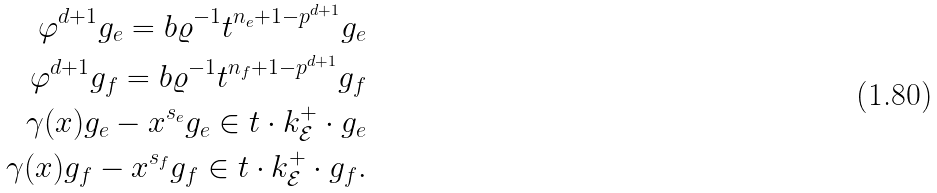Convert formula to latex. <formula><loc_0><loc_0><loc_500><loc_500>\varphi ^ { d + 1 } g _ { e } = b \varrho ^ { - 1 } t ^ { n _ { e } + 1 - p ^ { d + 1 } } g _ { e } \\ \varphi ^ { d + 1 } g _ { f } = b \varrho ^ { - 1 } t ^ { n _ { f } + 1 - p ^ { d + 1 } } g _ { f } \\ \gamma ( x ) g _ { e } - x ^ { s _ { e } } g _ { e } \in t \cdot k _ { \mathcal { E } } ^ { + } \cdot g _ { e } \\ \gamma ( x ) g _ { f } - x ^ { s _ { f } } g _ { f } \in t \cdot k _ { \mathcal { E } } ^ { + } \cdot g _ { f } .</formula> 